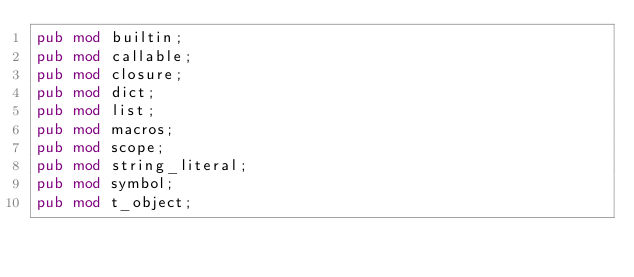<code> <loc_0><loc_0><loc_500><loc_500><_Rust_>pub mod builtin;
pub mod callable;
pub mod closure;
pub mod dict;
pub mod list;
pub mod macros;
pub mod scope;
pub mod string_literal;
pub mod symbol;
pub mod t_object;
</code> 